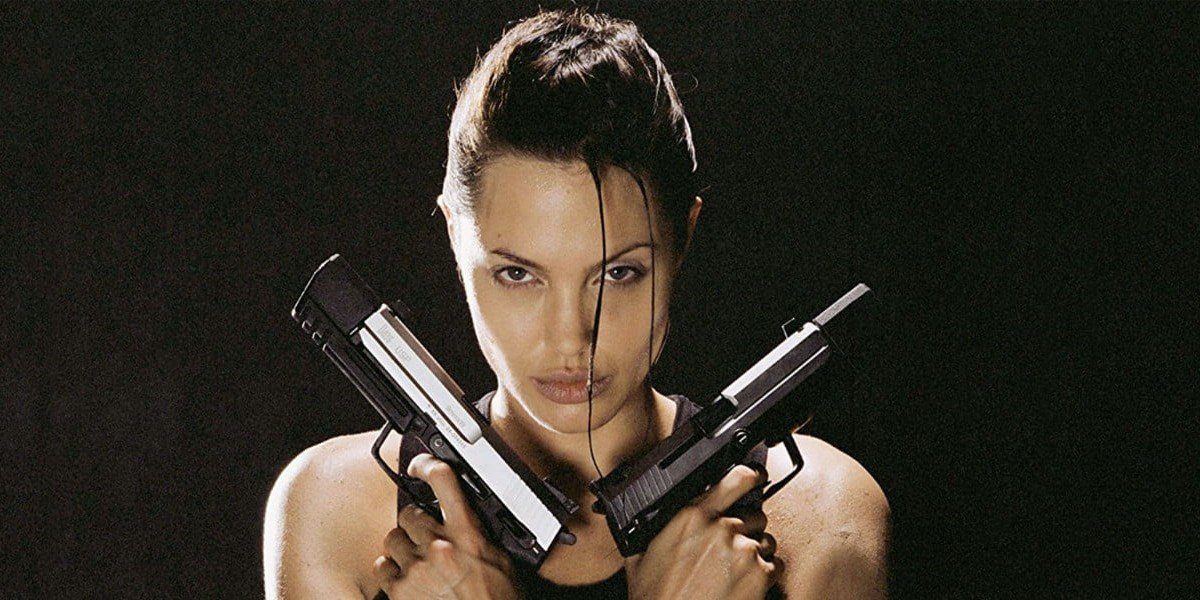Imagine this character in an unexpected scenario. What could unfold? Imagine the character, known for her combat skills and adventures, suddenly finding herself in a peaceful, quiet village that hasn’t seen conflict for years. Initially, the villagers are wary of her stern appearance, but as days pass, she starts helping out with their daily tasks while staying alert for any sign of danger. Unexpectedly, she bonds with the villagers, showing a softer, nurturing side that is usually hidden behind her warrior persona. One day, a threat appears on the horizon, and she seamlessly transitions back into her role as a protector, demonstrating her versatility and depth as a character. 